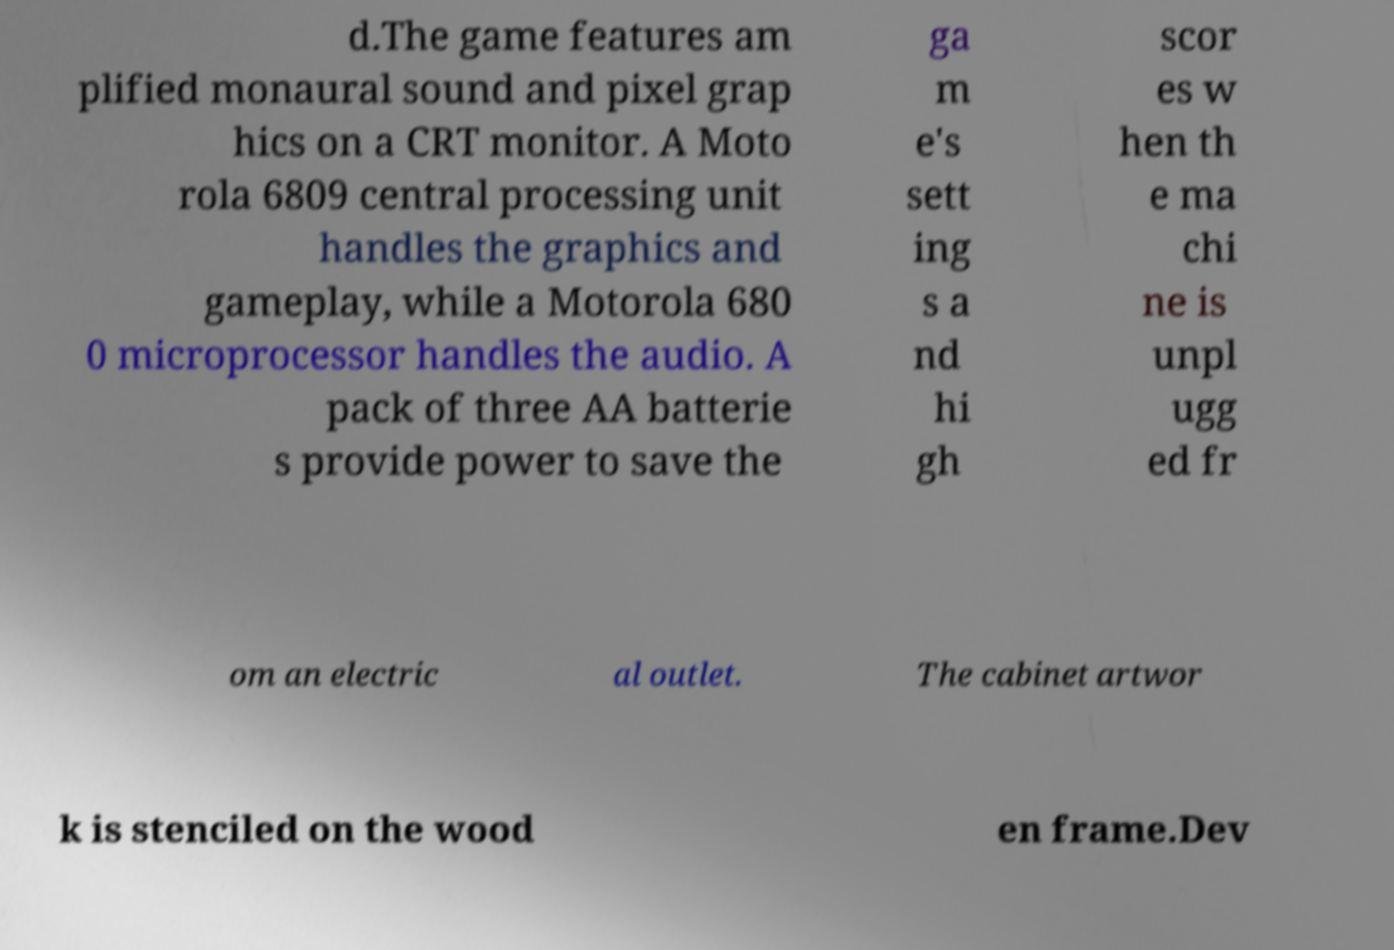Please read and relay the text visible in this image. What does it say? d.The game features am plified monaural sound and pixel grap hics on a CRT monitor. A Moto rola 6809 central processing unit handles the graphics and gameplay, while a Motorola 680 0 microprocessor handles the audio. A pack of three AA batterie s provide power to save the ga m e's sett ing s a nd hi gh scor es w hen th e ma chi ne is unpl ugg ed fr om an electric al outlet. The cabinet artwor k is stenciled on the wood en frame.Dev 